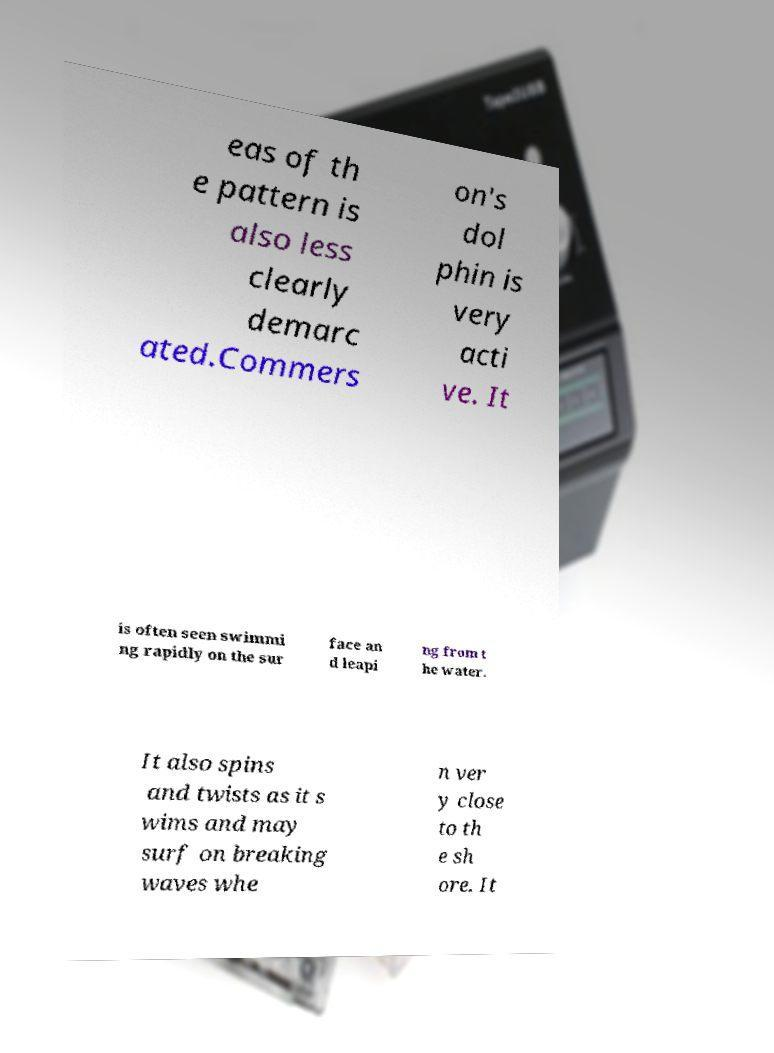I need the written content from this picture converted into text. Can you do that? eas of th e pattern is also less clearly demarc ated.Commers on's dol phin is very acti ve. It is often seen swimmi ng rapidly on the sur face an d leapi ng from t he water. It also spins and twists as it s wims and may surf on breaking waves whe n ver y close to th e sh ore. It 